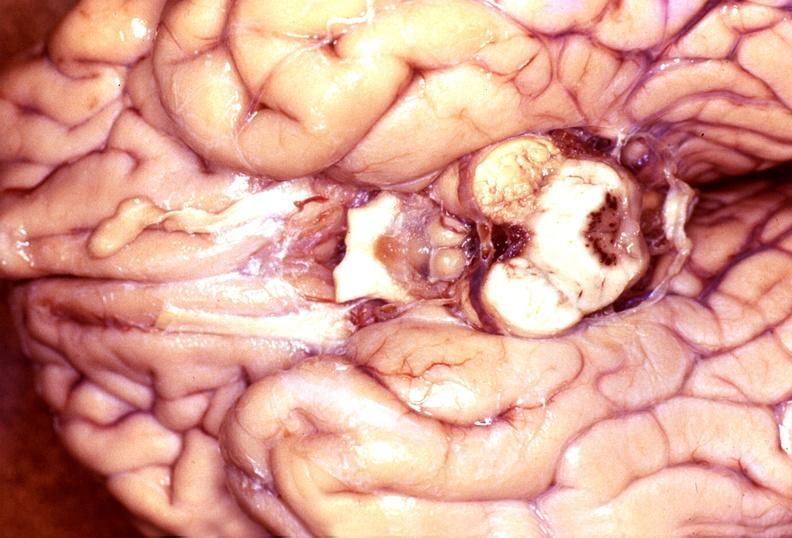does this image show wernicke 's encephalopathy?
Answer the question using a single word or phrase. Yes 